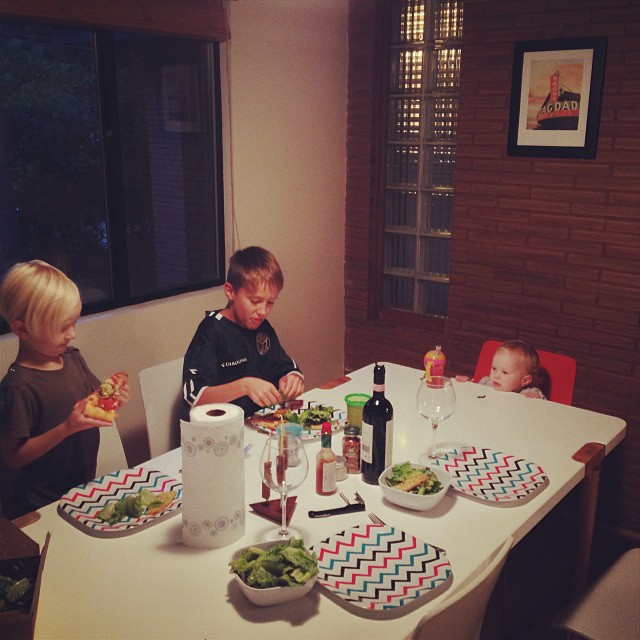Identify and read out the text in this image. AGDAD 